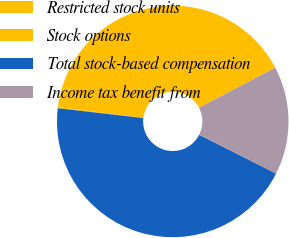Convert chart. <chart><loc_0><loc_0><loc_500><loc_500><pie_chart><fcel>Restricted stock units<fcel>Stock options<fcel>Total stock-based compensation<fcel>Income tax benefit from<nl><fcel>40.35%<fcel>0.15%<fcel>44.39%<fcel>15.11%<nl></chart> 